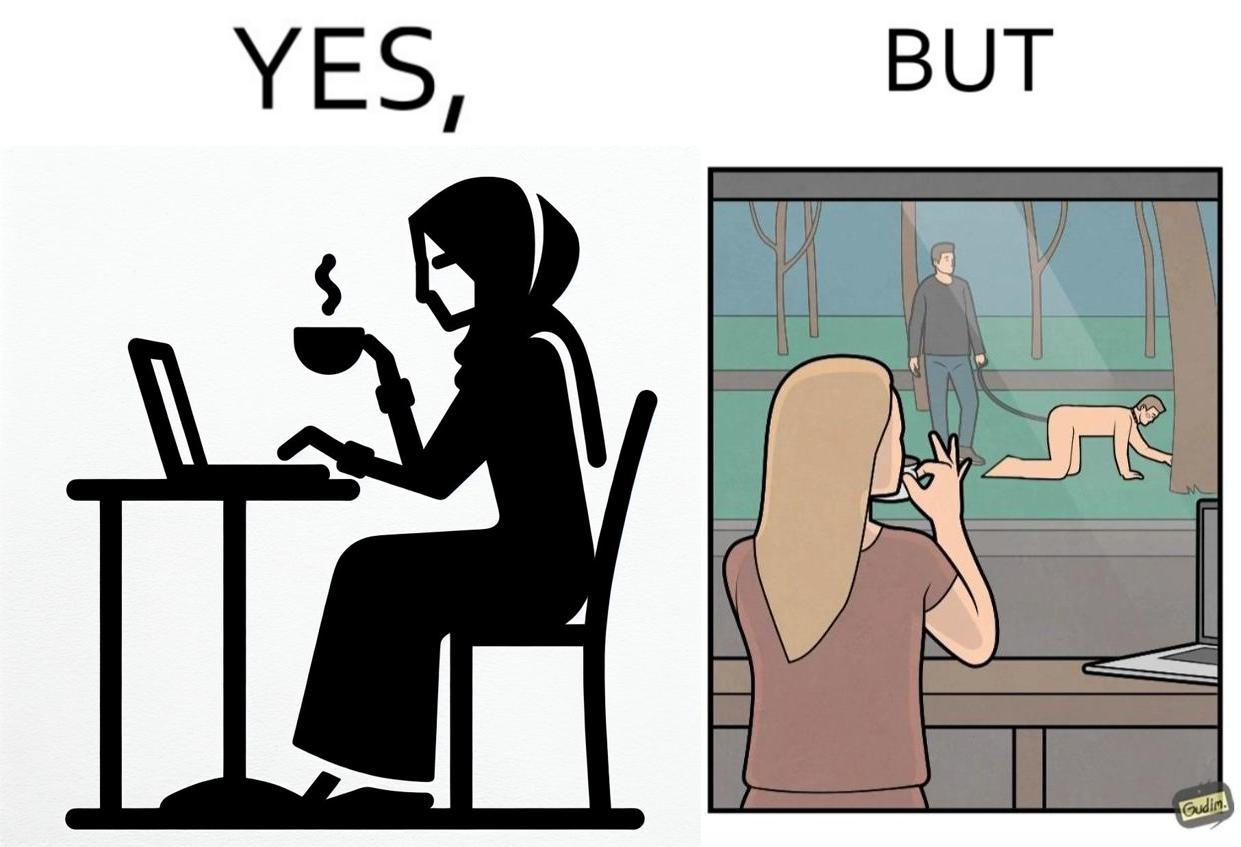What is shown in this image? The image is ironic, because in the first image a woman is seen enjoying her coffee, while watching the injustice happening outside without even having a single thought on the injustice outside and taking some actions or raising some concerns over it 